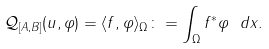Convert formula to latex. <formula><loc_0><loc_0><loc_500><loc_500>\mathcal { Q } _ { [ A , B ] } ( u , \varphi ) = \langle f , \varphi \rangle _ { \Omega } \colon = \int _ { \Omega } f ^ { * } \varphi \ d x .</formula> 